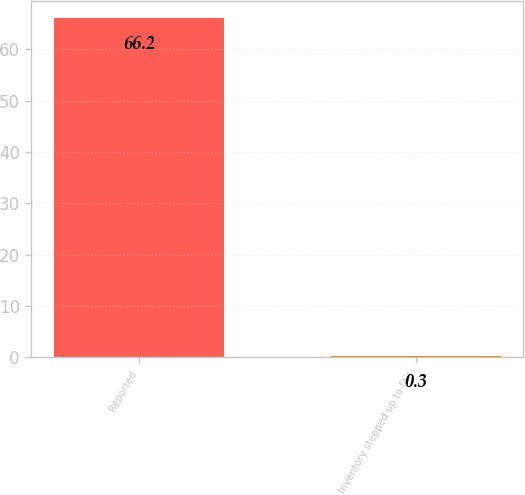Convert chart to OTSL. <chart><loc_0><loc_0><loc_500><loc_500><bar_chart><fcel>Reported<fcel>Inventory stepped up to fair<nl><fcel>66.2<fcel>0.3<nl></chart> 